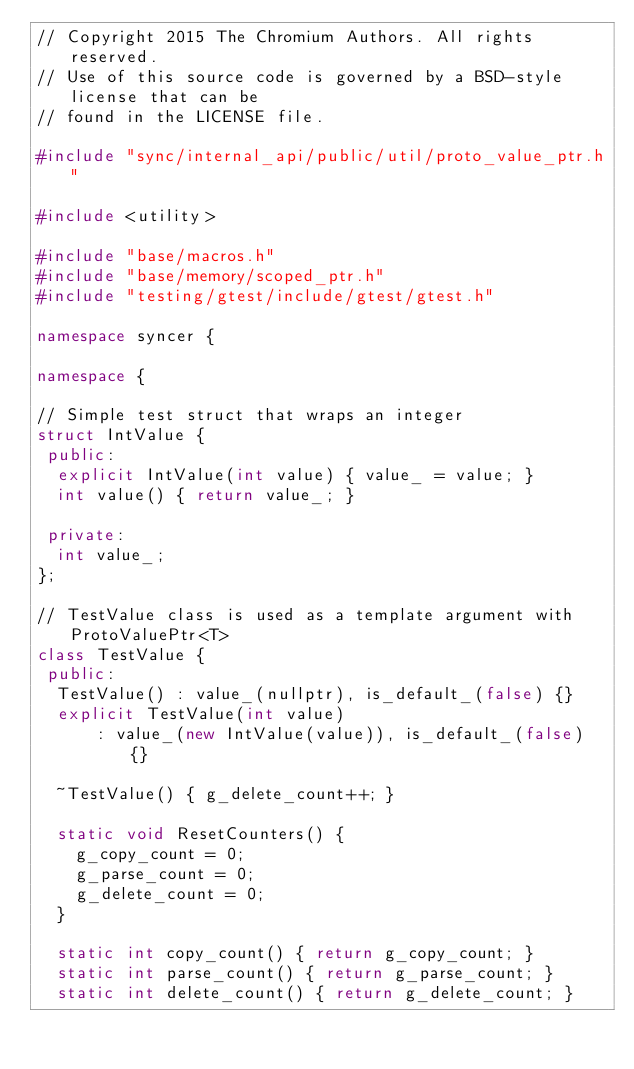<code> <loc_0><loc_0><loc_500><loc_500><_C++_>// Copyright 2015 The Chromium Authors. All rights reserved.
// Use of this source code is governed by a BSD-style license that can be
// found in the LICENSE file.

#include "sync/internal_api/public/util/proto_value_ptr.h"

#include <utility>

#include "base/macros.h"
#include "base/memory/scoped_ptr.h"
#include "testing/gtest/include/gtest/gtest.h"

namespace syncer {

namespace {

// Simple test struct that wraps an integer
struct IntValue {
 public:
  explicit IntValue(int value) { value_ = value; }
  int value() { return value_; }

 private:
  int value_;
};

// TestValue class is used as a template argument with ProtoValuePtr<T>
class TestValue {
 public:
  TestValue() : value_(nullptr), is_default_(false) {}
  explicit TestValue(int value)
      : value_(new IntValue(value)), is_default_(false) {}

  ~TestValue() { g_delete_count++; }

  static void ResetCounters() {
    g_copy_count = 0;
    g_parse_count = 0;
    g_delete_count = 0;
  }

  static int copy_count() { return g_copy_count; }
  static int parse_count() { return g_parse_count; }
  static int delete_count() { return g_delete_count; }
</code> 